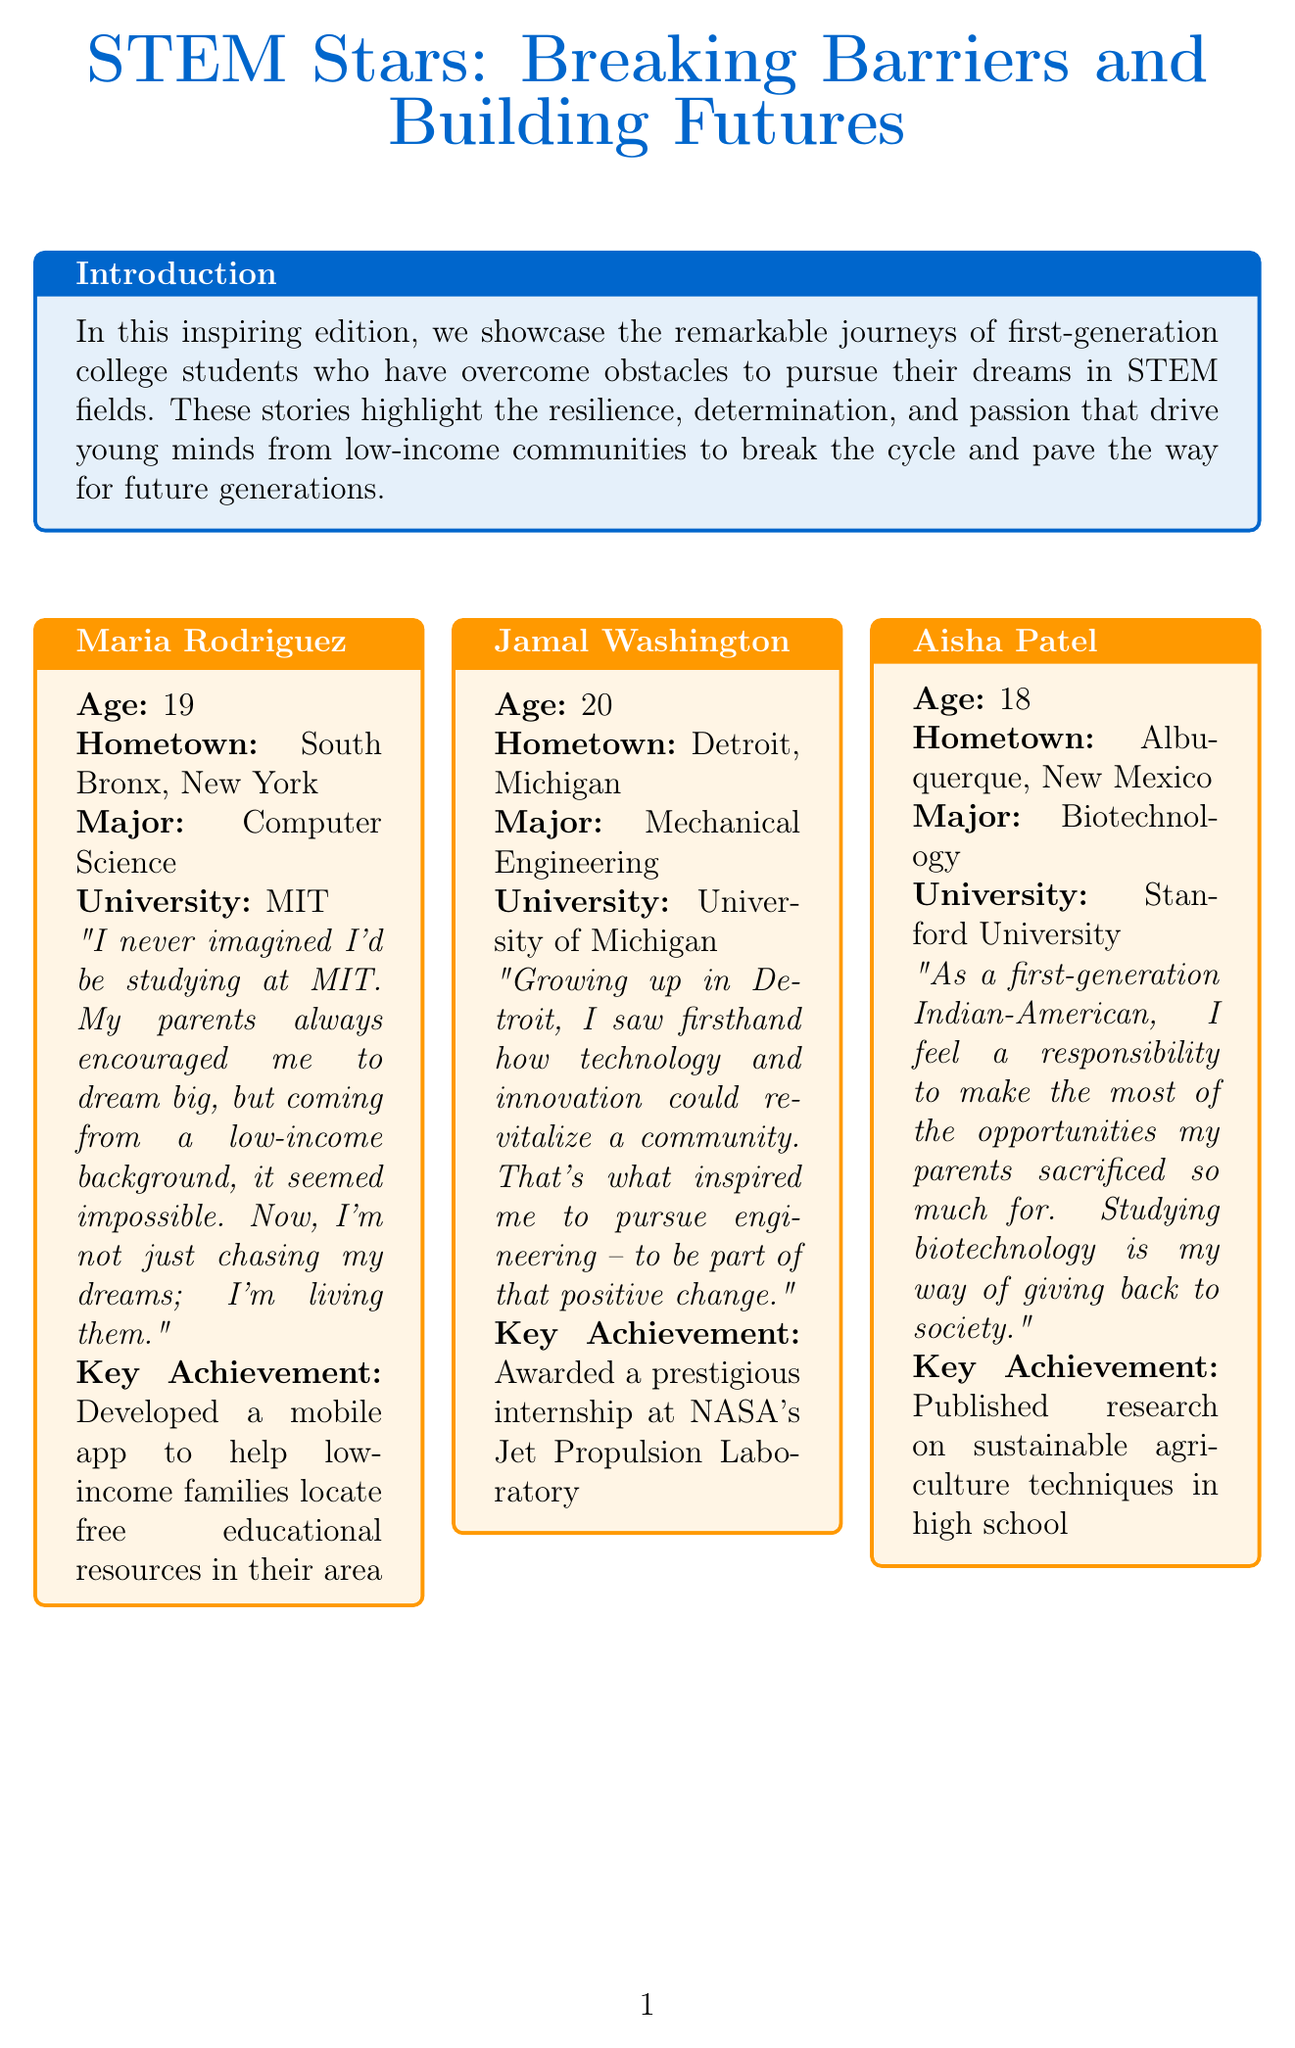What is the title of the newsletter? The title is mentioned at the beginning of the document, showcasing its theme about inspiring stories in STEM.
Answer: STEM Stars: Breaking Barriers and Building Futures Who is featured as the first student in the newsletter? The first student is highlighted in the featured stories section, providing her background and accomplishments.
Answer: Maria Rodriguez How old is Jamal Washington? Jamal’s age is provided in his story along with other details.
Answer: 20 What does Aisha Patel aim to give back to? Aisha's quote expresses her motivation related to her cultural background and her academic pursuit.
Answer: Society What program is described as providing support to high school students from low-income families? This program aims to enhance math and science skills for eligible students.
Answer: Upward Bound Math-Science Program What prestigious internship did Jamal Washington receive? The specific internship highlights Jamal's achievement and the organization he will be working with.
Answer: NASA's Jet Propulsion Laboratory Which scholarship program provides support specifically for women pursuing engineering? The document lists various scholarships, including one that targets a specific demographic in engineering.
Answer: Society of Women Engineers Scholarships What is one of the emerging careers in STEM mentioned? This question asks for a specific example from the list of careers shaping the future.
Answer: Artificial Intelligence Specialist 